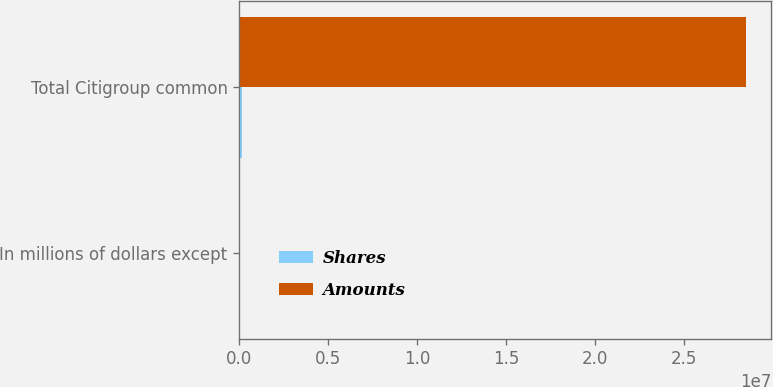<chart> <loc_0><loc_0><loc_500><loc_500><stacked_bar_chart><ecel><fcel>In millions of dollars except<fcel>Total Citigroup common<nl><fcel>Shares<fcel>2009<fcel>152388<nl><fcel>Amounts<fcel>2009<fcel>2.84833e+07<nl></chart> 